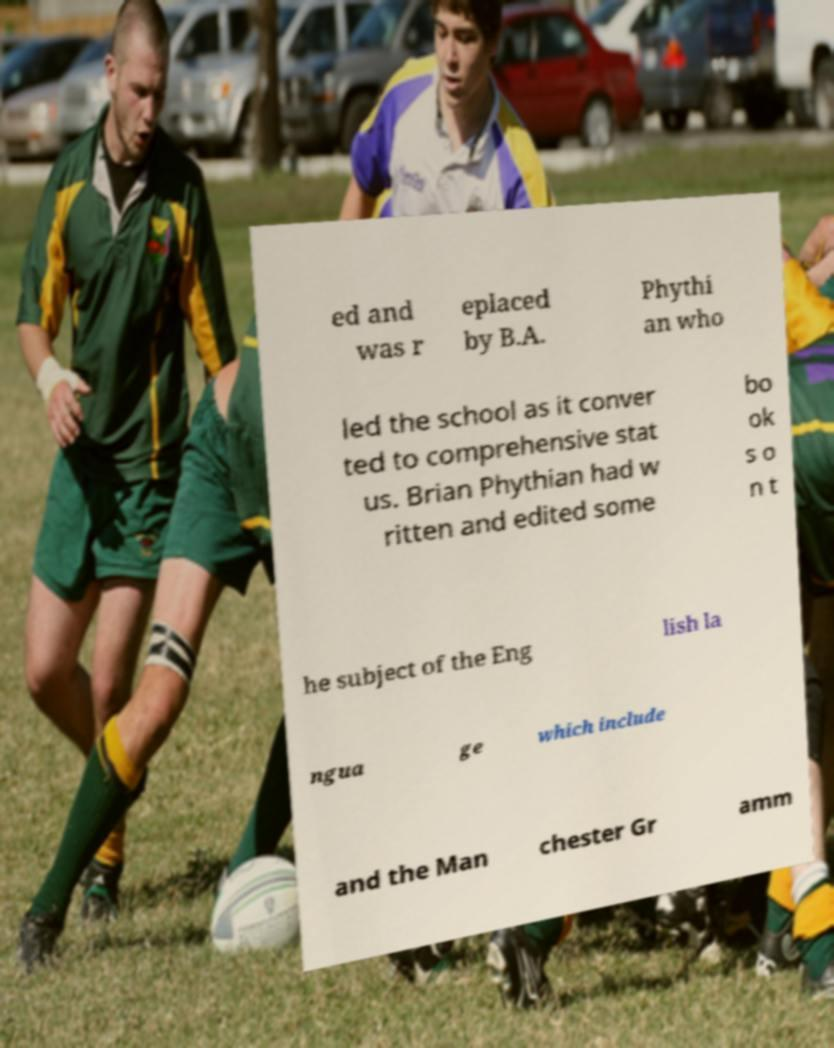Can you accurately transcribe the text from the provided image for me? ed and was r eplaced by B.A. Phythi an who led the school as it conver ted to comprehensive stat us. Brian Phythian had w ritten and edited some bo ok s o n t he subject of the Eng lish la ngua ge which include and the Man chester Gr amm 